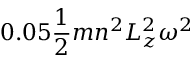<formula> <loc_0><loc_0><loc_500><loc_500>0 . 0 5 \frac { 1 } { 2 } m n ^ { 2 } L _ { z } ^ { 2 } \omega ^ { 2 }</formula> 